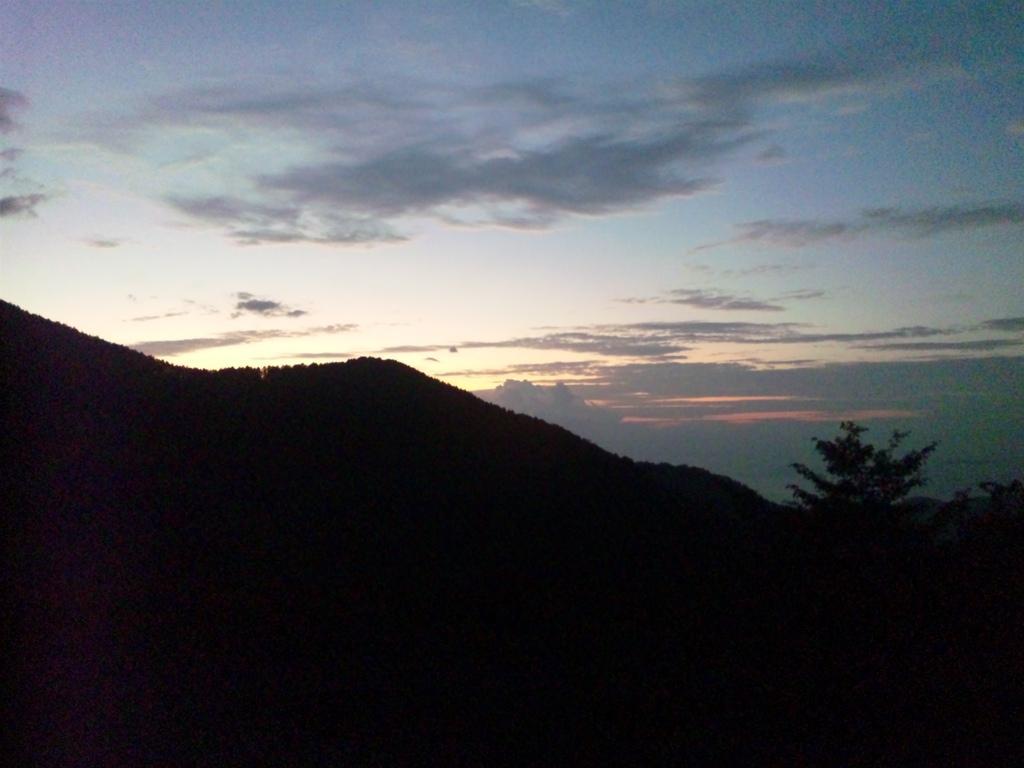Can you describe this image briefly? In the image there are mountains and on the right side there is a tree, in the background there is a sky. 